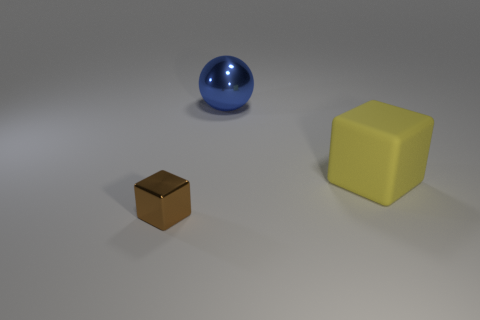Add 1 big cubes. How many objects exist? 4 Subtract all brown cubes. How many cubes are left? 1 Subtract 1 cubes. How many cubes are left? 1 Subtract all large yellow blocks. Subtract all big blue spheres. How many objects are left? 1 Add 3 small brown objects. How many small brown objects are left? 4 Add 3 small blue cylinders. How many small blue cylinders exist? 3 Subtract 0 blue cylinders. How many objects are left? 3 Subtract all blocks. How many objects are left? 1 Subtract all red blocks. Subtract all blue cylinders. How many blocks are left? 2 Subtract all cyan balls. How many gray cubes are left? 0 